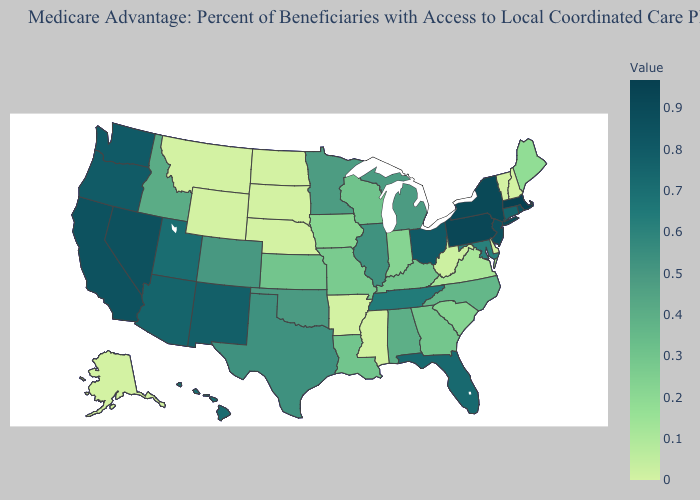Which states have the lowest value in the South?
Concise answer only. Arkansas, Delaware, Mississippi. Among the states that border Montana , does North Dakota have the highest value?
Give a very brief answer. No. Which states have the lowest value in the South?
Answer briefly. Arkansas, Delaware, Mississippi. Is the legend a continuous bar?
Write a very short answer. Yes. Is the legend a continuous bar?
Write a very short answer. Yes. Which states have the lowest value in the USA?
Keep it brief. Alaska, Arkansas, Delaware, Mississippi, Montana, North Dakota, Nebraska, New Hampshire, South Dakota, Vermont, Wyoming. Is the legend a continuous bar?
Be succinct. Yes. Does Ohio have the highest value in the MidWest?
Keep it brief. Yes. Does the map have missing data?
Give a very brief answer. No. 